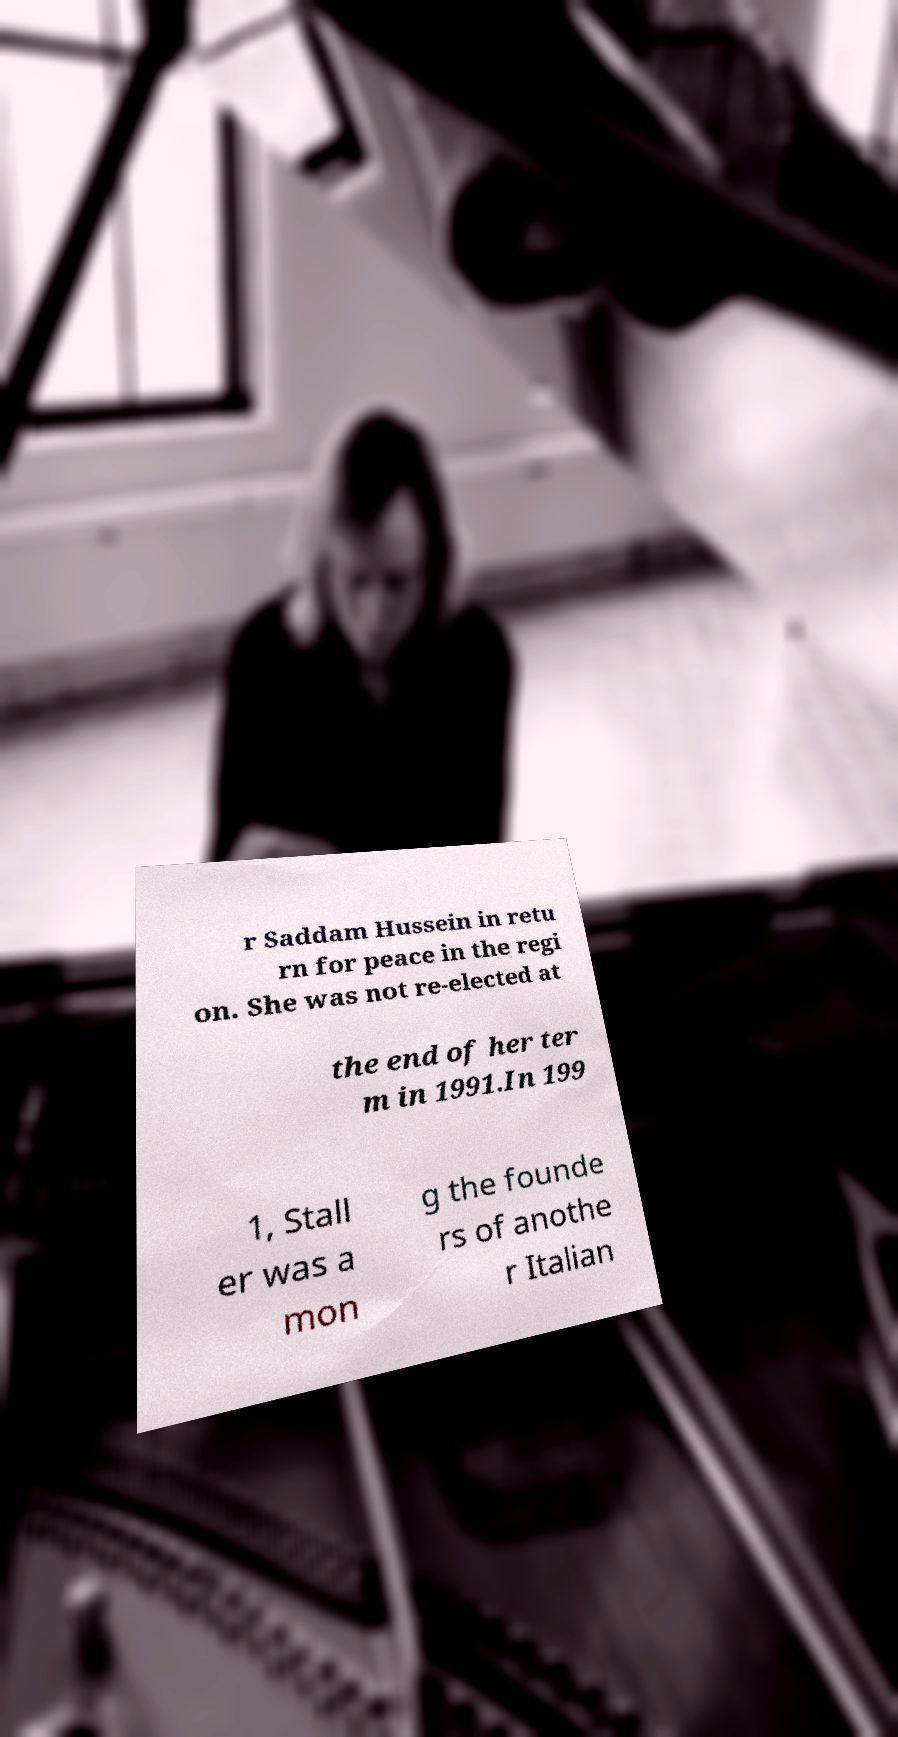What messages or text are displayed in this image? I need them in a readable, typed format. r Saddam Hussein in retu rn for peace in the regi on. She was not re-elected at the end of her ter m in 1991.In 199 1, Stall er was a mon g the founde rs of anothe r Italian 